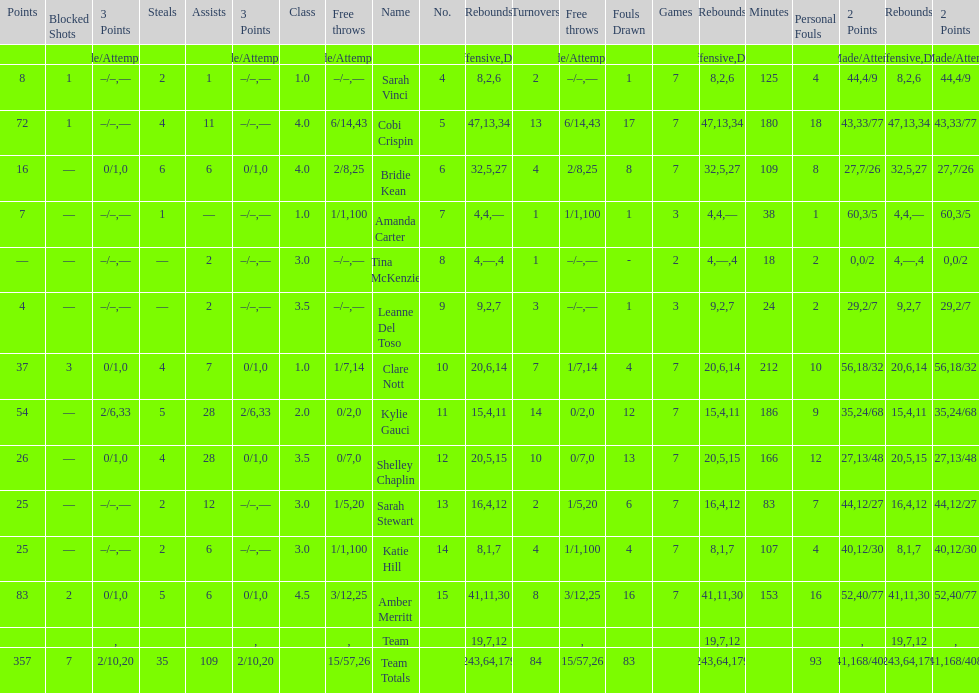Who is the last player on the list to not attempt a 3 point shot? Katie Hill. 